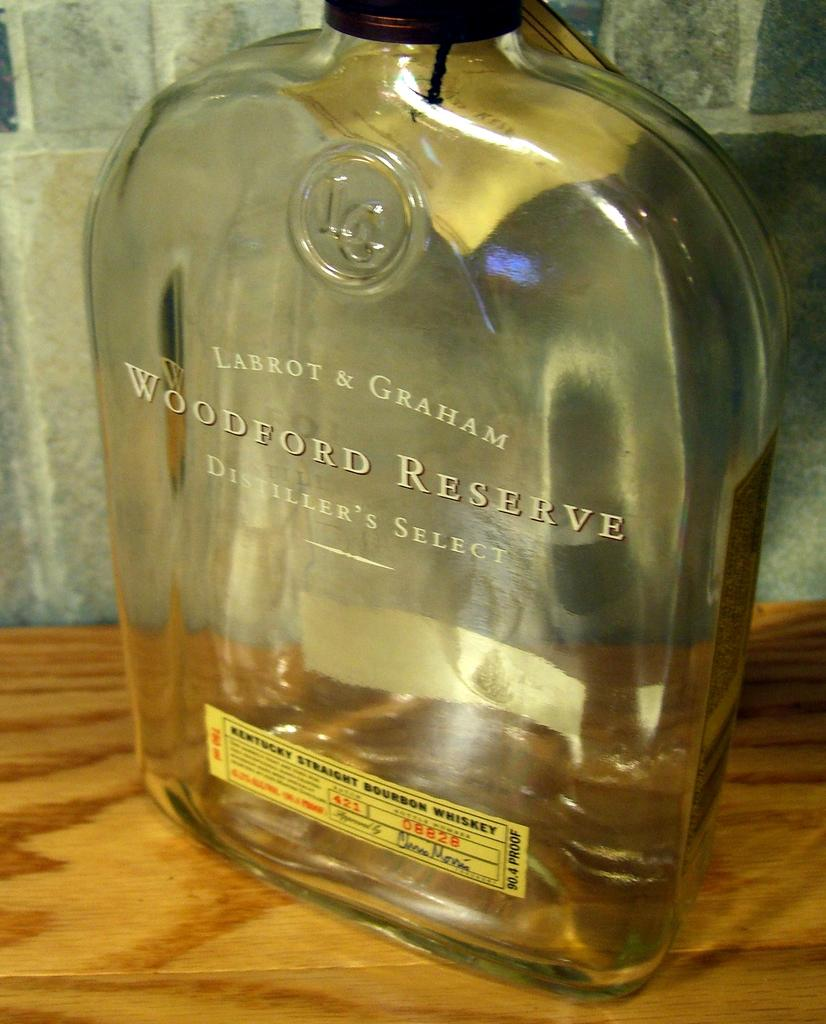<image>
Render a clear and concise summary of the photo. A large bottle of Woodford Reserve Distiller's Select 